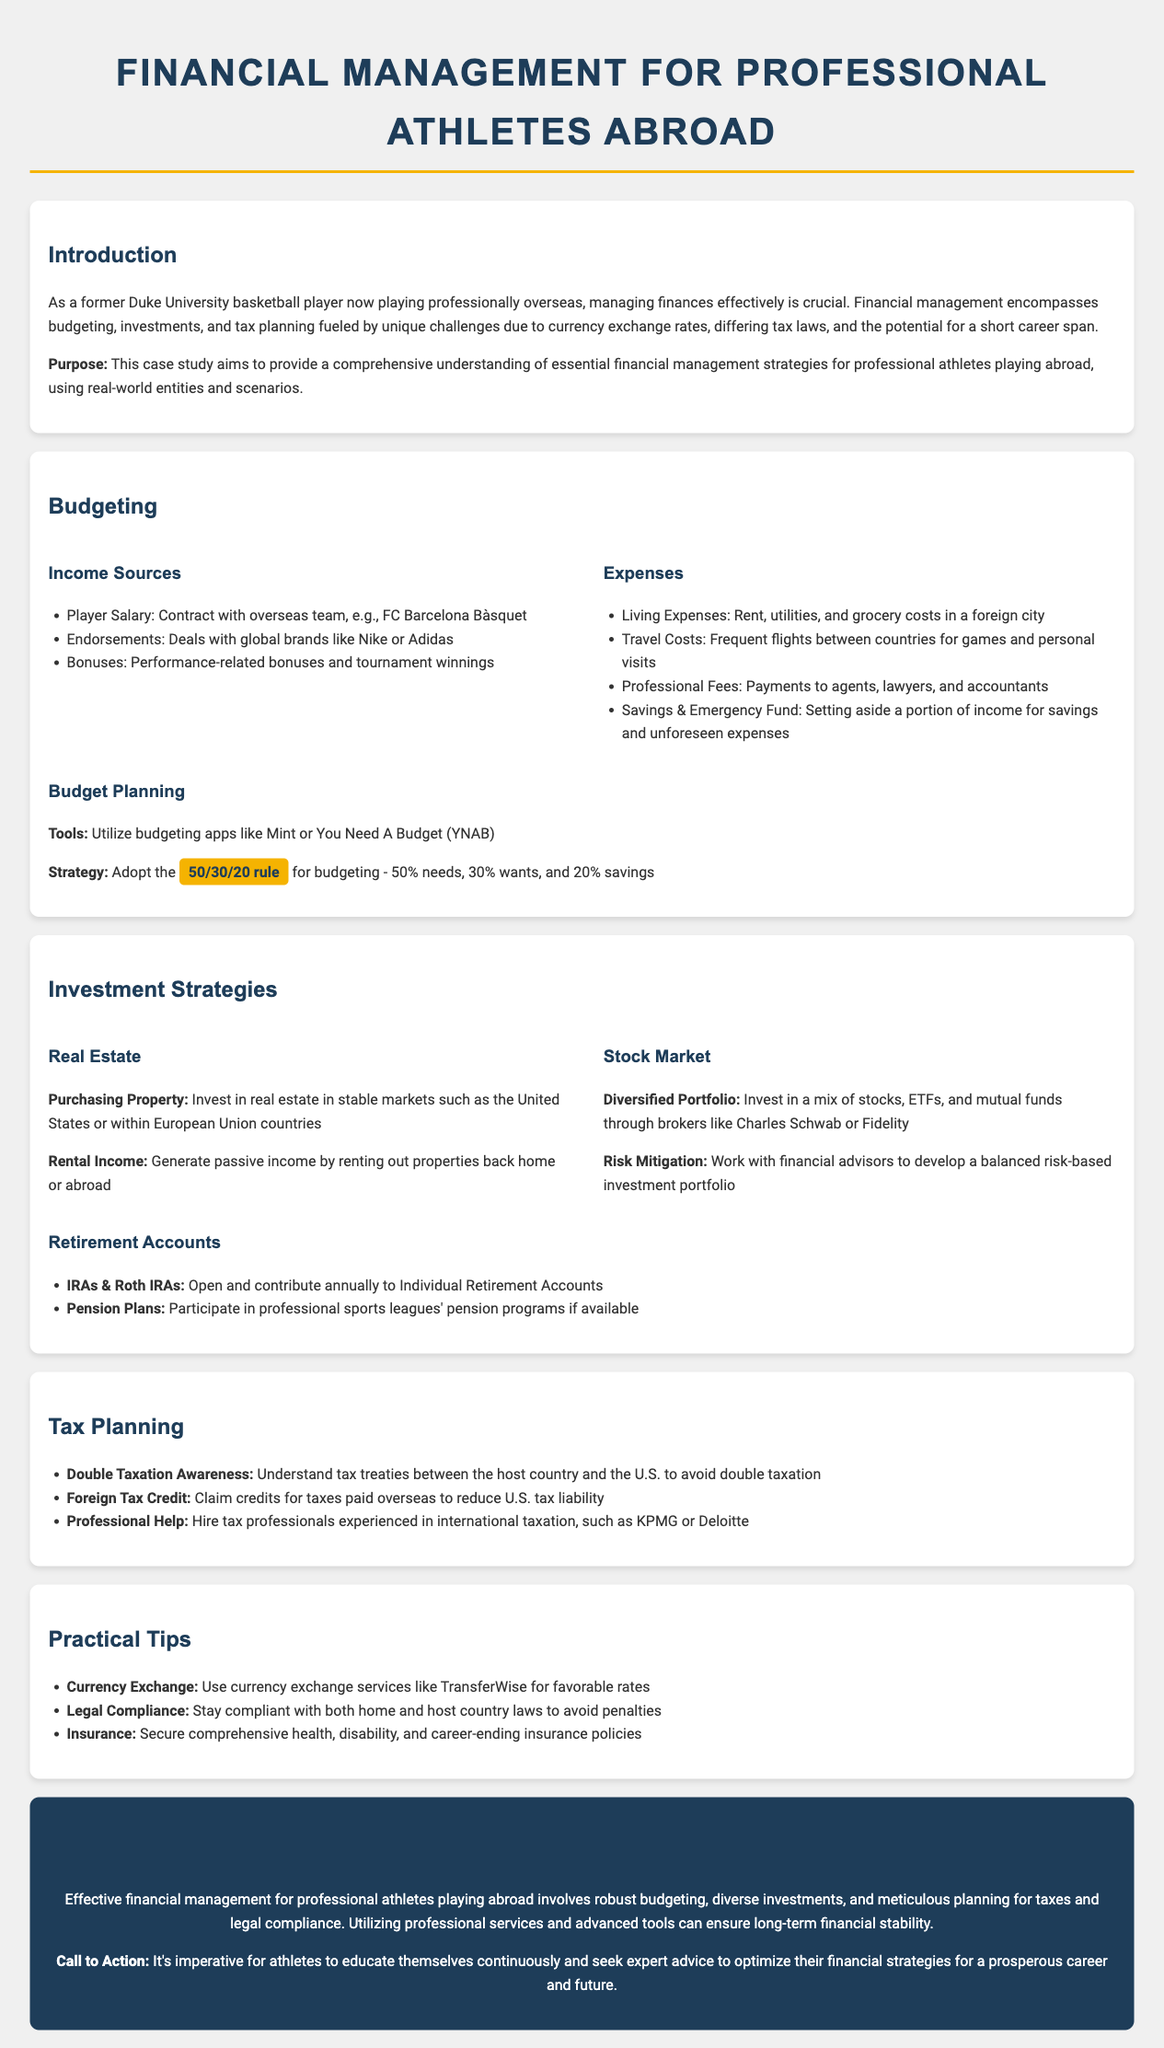What is the purpose of the case study? The purpose of the case study is to provide a comprehensive understanding of essential financial management strategies for professional athletes playing abroad.
Answer: Comprehensive understanding of essential financial management strategies What is one income source mentioned for athletes? One income source mentioned is the player salary, specifically a contract with an overseas team.
Answer: Player salary What is the recommended budgeting rule? The document suggests adopting the 50/30/20 rule for budgeting which allocates percentages for needs, wants, and savings.
Answer: 50/30/20 rule Which investment option is discussed for generating passive income? The document discusses purchasing property as an investment option that can generate rental income.
Answer: Purchasing property What tax credit can athletes claim to reduce U.S. tax liability? Athletes can claim the Foreign Tax Credit to reduce their U.S. tax liability.
Answer: Foreign Tax Credit What is a practical tip for currency exchange? A practical tip provided is to use currency exchange services like TransferWise for favorable rates.
Answer: TransferWise Who should athletes hire for tax-related assistance? Athletes are advised to hire tax professionals experienced in international taxation, like KPMG or Deloitte.
Answer: KPMG or Deloitte What is one suggested type of insurance for athletes? Securing comprehensive health insurance is suggested as one type of insurance for athletes.
Answer: Health insurance 